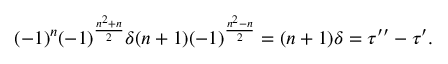Convert formula to latex. <formula><loc_0><loc_0><loc_500><loc_500>( - 1 ) ^ { n } ( - 1 ) ^ { \frac { n ^ { 2 } + n } { 2 } } \delta ( n + 1 ) ( - 1 ) ^ { \frac { n ^ { 2 } - n } { 2 } } = ( n + 1 ) \delta = \tau ^ { \prime \prime } - \tau ^ { \prime } .</formula> 